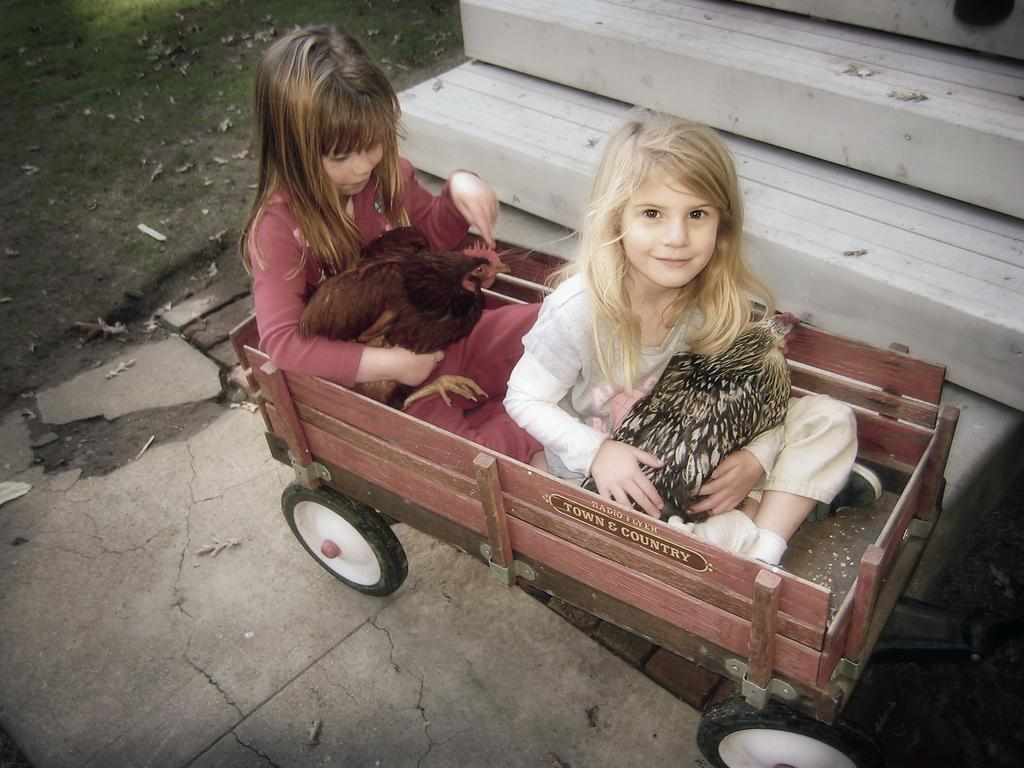Who or what can be seen in the image? There are people and hens in the image. What are the hens doing in the image? The hens are sitting on an object in the image. What type of surface is visible beneath the hens? There is ground visible in the image, and it has grass on it. Are there any architectural features in the image? Yes, there are stairs in the image. What type of watch is the hen wearing in the image? There are no watches present in the image, as hens do not wear watches. Can you tell me the brand of the shoe the person is wearing in the image? There are no shoes visible in the image, so it is not possible to determine the brand of any shoe. 